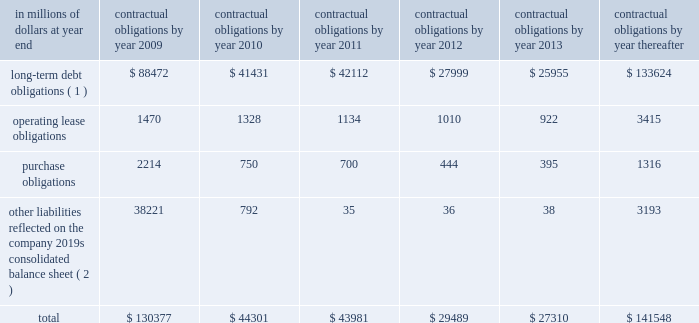Contractual obligations the table includes aggregated information about citigroup 2019s contractual obligations that impact its short- and long-term liquidity and capital needs .
The table includes information about payments due under specified contractual obligations , aggregated by type of contractual obligation .
It includes the maturity profile of the company 2019s consolidated long-term debt , operating leases and other long-term liabilities .
The company 2019s capital lease obligations are included in purchase obligations in the table .
Citigroup 2019s contractual obligations include purchase obligations that are enforceable and legally binding for the company .
For the purposes of the table below , purchase obligations are included through the termination date of the respective agreements , even if the contract is renewable .
Many of the purchase agreements for goods or services include clauses that would allow the company to cancel the agreement with specified notice ; however , that impact is not included in the table ( unless citigroup has already notified the counterparty of its intention to terminate the agreement ) .
Other liabilities reflected on the company 2019s consolidated balance sheet include obligations for goods and services that have already been received , litigation settlements , uncertain tax positions , as well as other long-term liabilities that have been incurred and will ultimately be paid in cash .
Excluded from the table are obligations that are generally short term in nature , including deposit liabilities and securities sold under agreements to repurchase .
The table also excludes certain insurance and investment contracts subject to mortality and morbidity risks or without defined maturities , such that the timing of payments and withdrawals is uncertain .
The liabilities related to these insurance and investment contracts are included on the consolidated balance sheet as insurance policy and claims reserves , contractholder funds , and separate and variable accounts .
Citigroup 2019s funding policy for pension plans is generally to fund to the minimum amounts required by the applicable laws and regulations .
At december 31 , 2008 , there were no minimum required contributions , and no contributions are currently planned for the u.s .
Pension plans .
Accordingly , no amounts have been included in the table below for future contributions to the u.s .
Pension plans .
For the non-u.s .
Plans , discretionary contributions in 2009 are anticipated to be approximately $ 167 million and this amount has been included in purchase obligations in the table below .
The estimated pension plan contributions are subject to change , since contribution decisions are affected by various factors , such as market performance , regulatory and legal requirements , and management 2019s ability to change funding policy .
For additional information regarding the company 2019s retirement benefit obligations , see note 9 to the consolidated financial statements on page 144. .
( 1 ) for additional information about long-term debt and trust preferred securities , see note 20 to the consolidated financial statements on page 169 .
( 2 ) relates primarily to accounts payable and accrued expenses included in other liabilities in the company 2019s consolidated balance sheet .
Also included are various litigation settlements. .
In 2009 what was the percent of the long-term debt obligations of the total contractual obligations? 
Computations: (88472 / 130377)
Answer: 0.67859. 